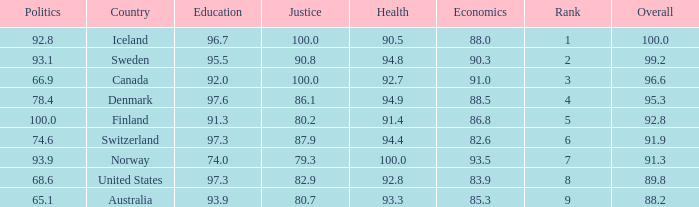What's the economics score with education being 92.0 91.0. 